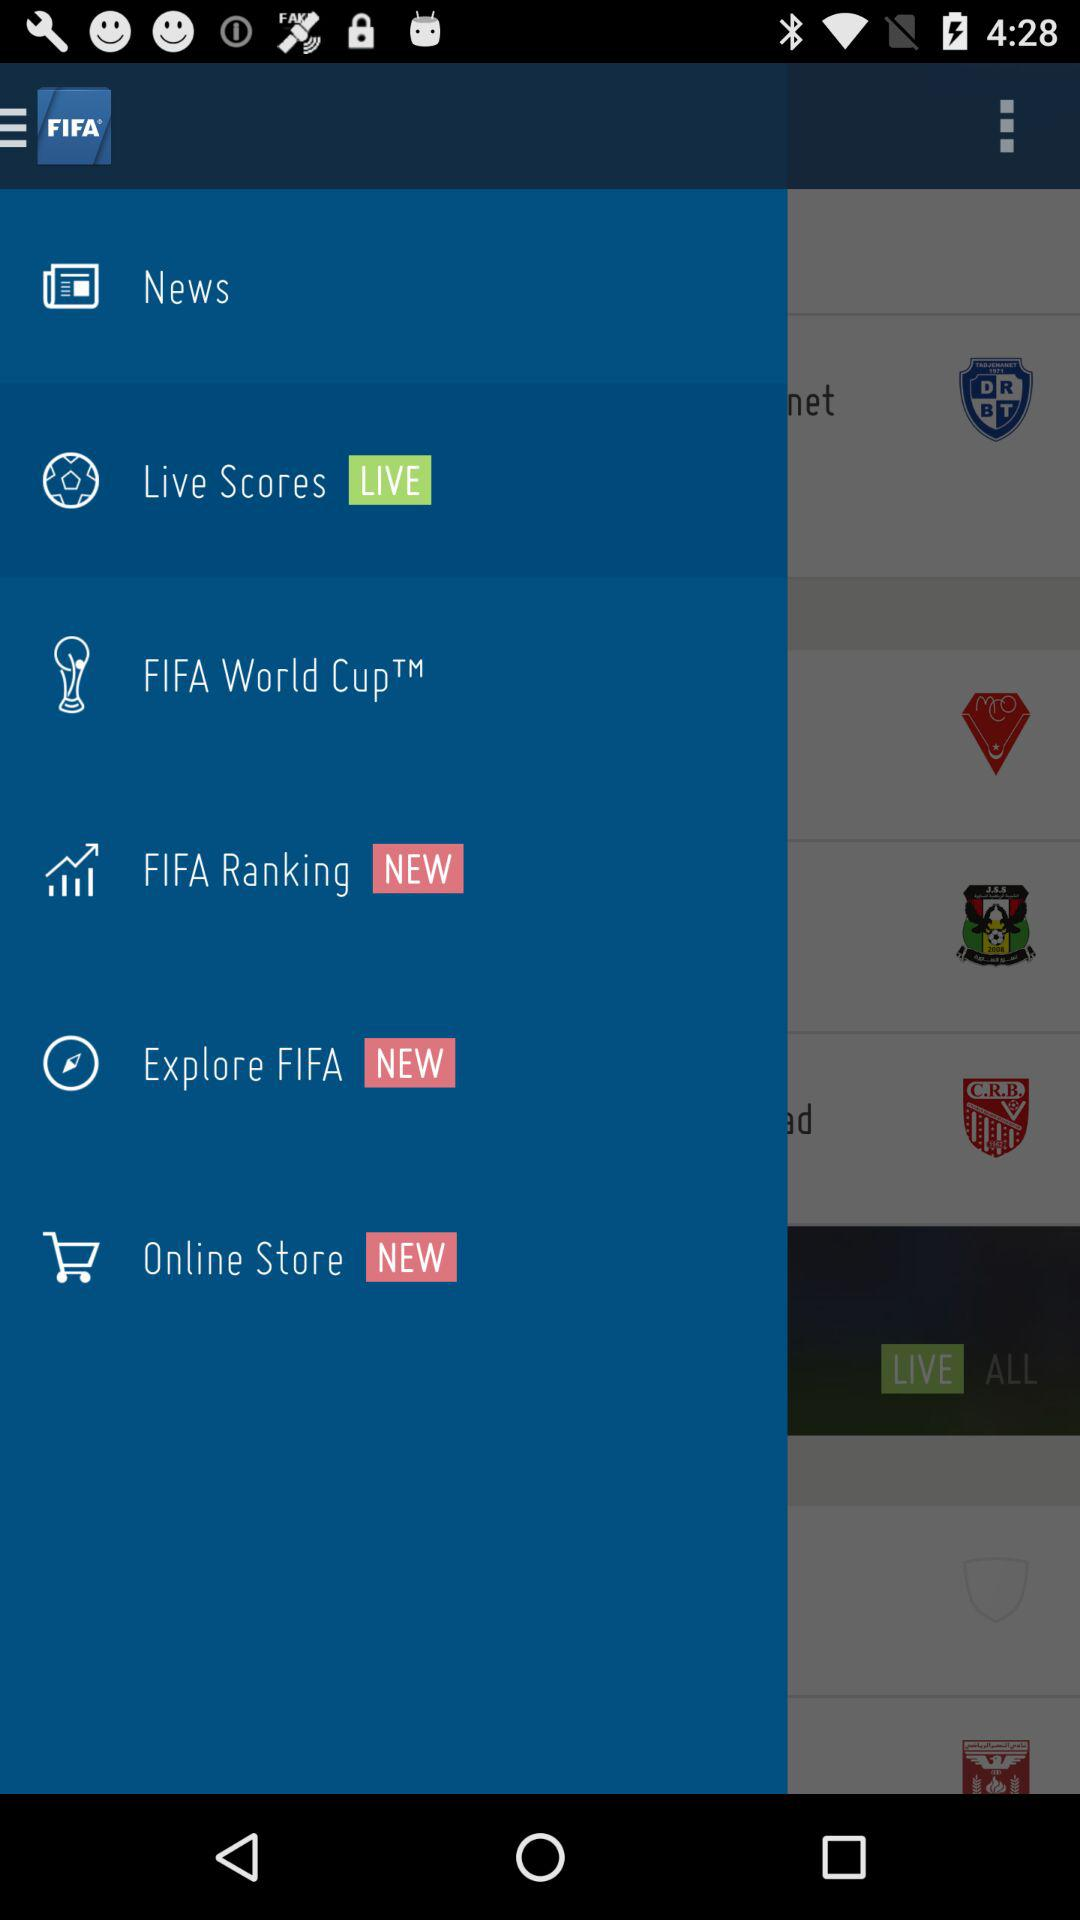What is the name of the application? The name of the application is "FIFA". 